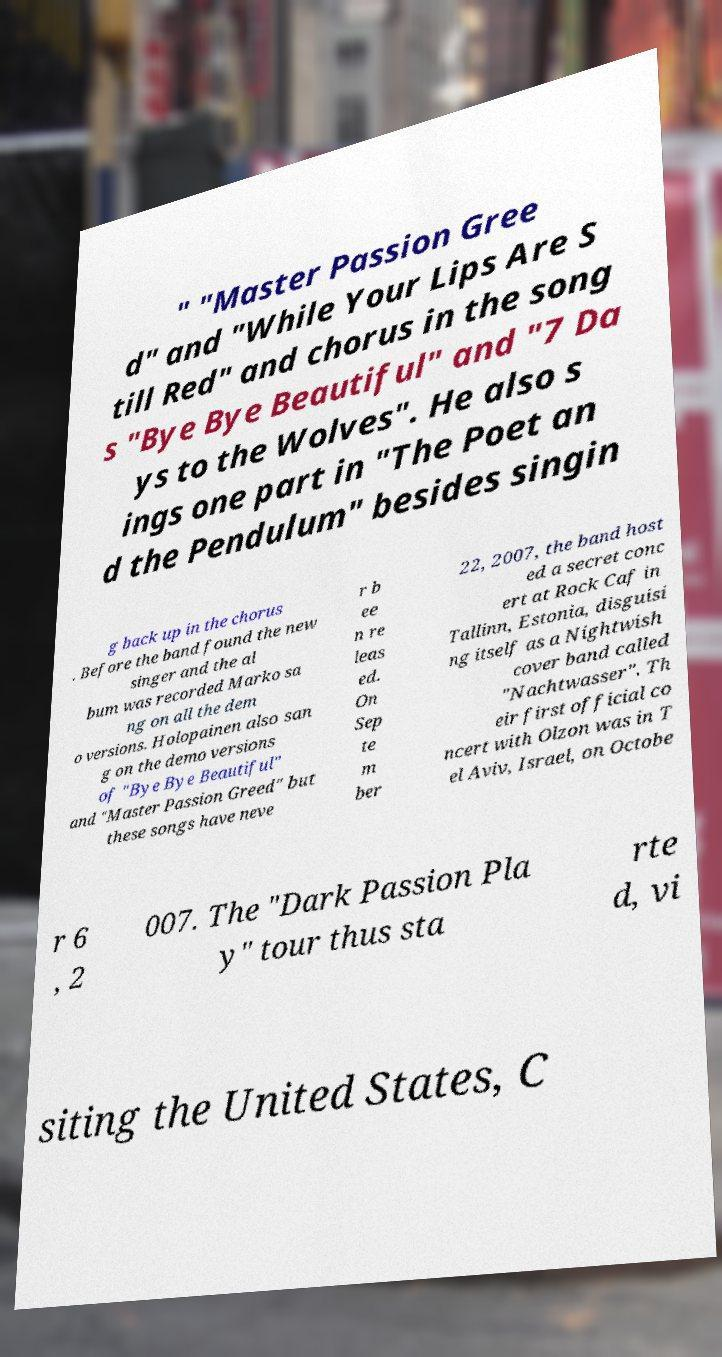Please read and relay the text visible in this image. What does it say? " "Master Passion Gree d" and "While Your Lips Are S till Red" and chorus in the song s "Bye Bye Beautiful" and "7 Da ys to the Wolves". He also s ings one part in "The Poet an d the Pendulum" besides singin g back up in the chorus . Before the band found the new singer and the al bum was recorded Marko sa ng on all the dem o versions. Holopainen also san g on the demo versions of "Bye Bye Beautiful" and "Master Passion Greed" but these songs have neve r b ee n re leas ed. On Sep te m ber 22, 2007, the band host ed a secret conc ert at Rock Caf in Tallinn, Estonia, disguisi ng itself as a Nightwish cover band called "Nachtwasser". Th eir first official co ncert with Olzon was in T el Aviv, Israel, on Octobe r 6 , 2 007. The "Dark Passion Pla y" tour thus sta rte d, vi siting the United States, C 